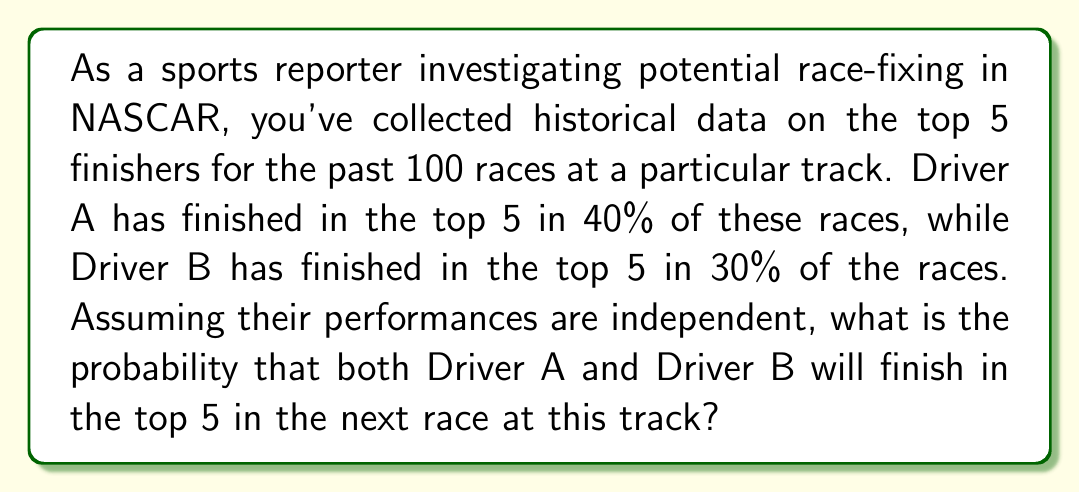Can you answer this question? To solve this problem, we'll use the concept of independent events in probability theory.

Step 1: Identify the probabilities for each driver.
P(A) = Probability of Driver A finishing in the top 5 = 40% = 0.4
P(B) = Probability of Driver B finishing in the top 5 = 30% = 0.3

Step 2: Since the events are independent, we can use the multiplication rule of probability.
For independent events, the probability of both events occurring is the product of their individual probabilities.

P(A and B) = P(A) × P(B)

Step 3: Calculate the probability.
P(A and B) = 0.4 × 0.3 = 0.12

Step 4: Convert the result to a percentage.
0.12 × 100% = 12%

Therefore, the probability that both Driver A and Driver B will finish in the top 5 in the next race at this track is 12%.
Answer: 12% 